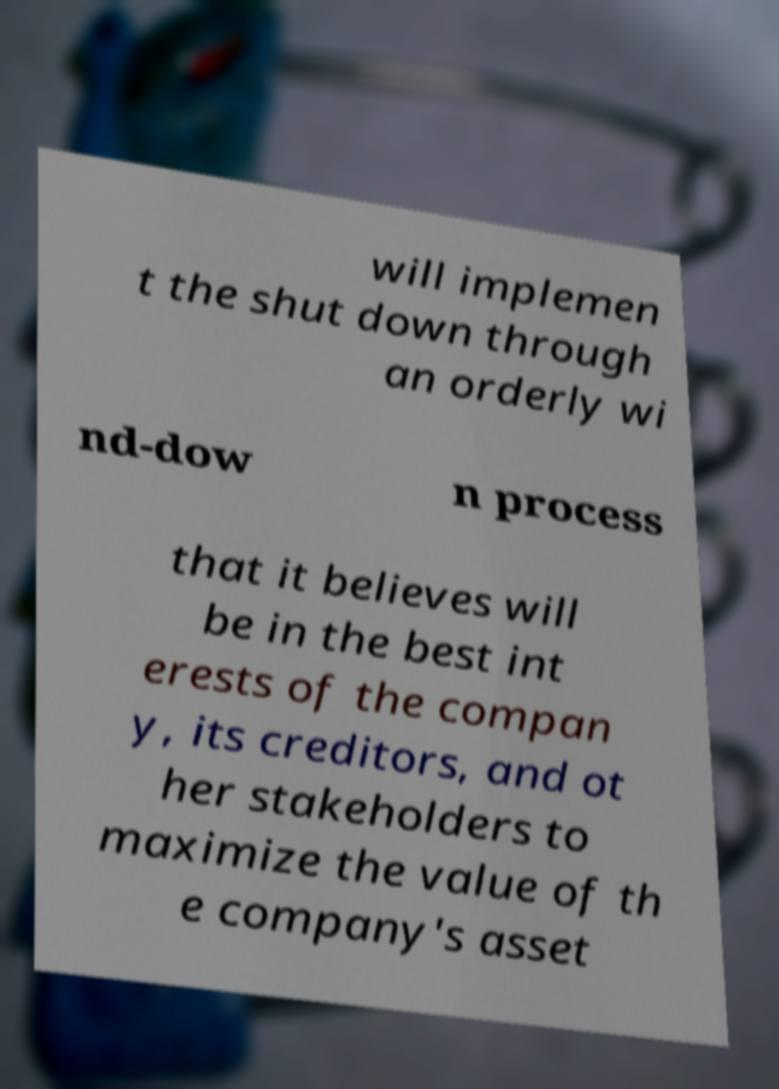There's text embedded in this image that I need extracted. Can you transcribe it verbatim? will implemen t the shut down through an orderly wi nd-dow n process that it believes will be in the best int erests of the compan y, its creditors, and ot her stakeholders to maximize the value of th e company's asset 